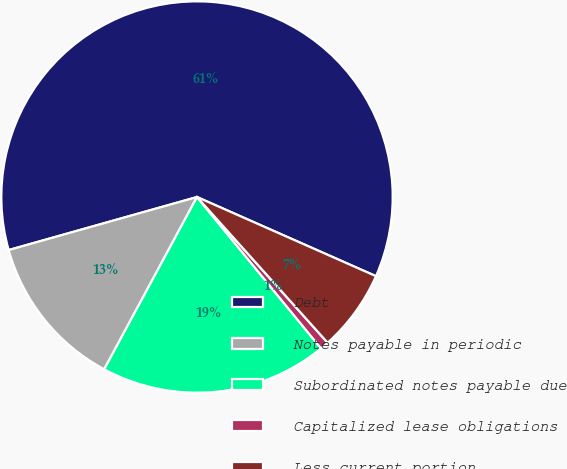Convert chart to OTSL. <chart><loc_0><loc_0><loc_500><loc_500><pie_chart><fcel>Debt<fcel>Notes payable in periodic<fcel>Subordinated notes payable due<fcel>Capitalized lease obligations<fcel>Less current portion<nl><fcel>61.0%<fcel>12.77%<fcel>18.79%<fcel>0.71%<fcel>6.74%<nl></chart> 